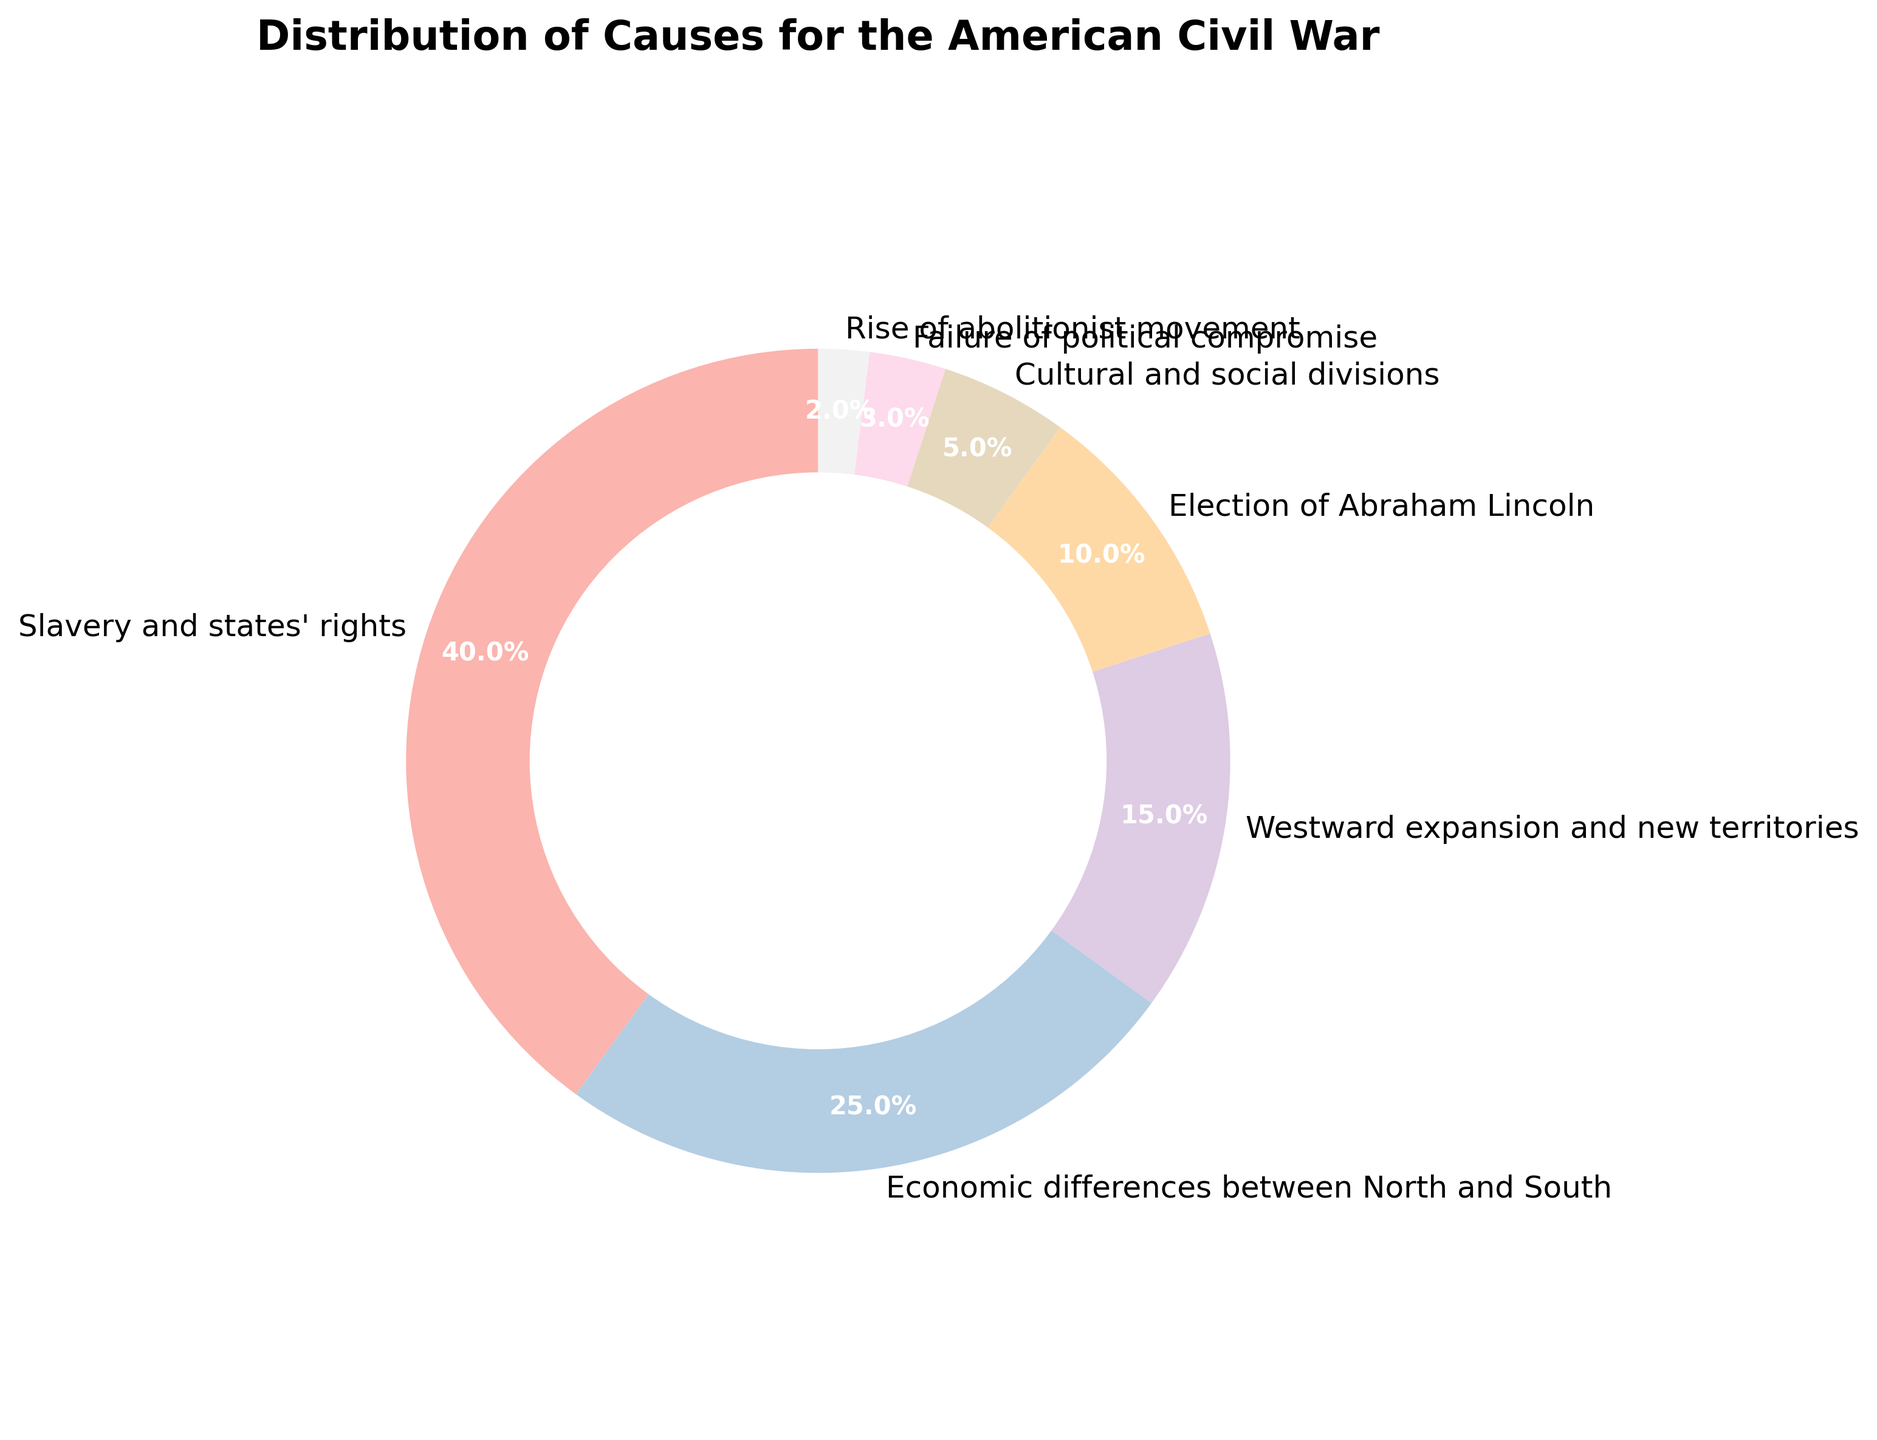What percentage of the causes is attributed to "Economic differences between North and South" and "Westward expansion and new territories" combined? First, identify the percentages for "Economic differences between North and South" (25%) and "Westward expansion and new territories" (15%). Then, add them together: 25% + 15% = 40%.
Answer: 40% How much greater is the percentage of "Slavery and states' rights" compared to the "Election of Abraham Lincoln"? First, look at the percentage of "Slavery and states' rights" (40%) and the percentage of "Election of Abraham Lincoln" (10%). Then, subtract the latter from the former: 40% - 10% = 30%.
Answer: 30% What percentage of the chart is attributed to causes that are less than 10% each? Identify the percentages of causes less than 10%: "Cultural and social divisions" (5%), "Failure of political compromise" (3%), and "Rise of abolitionist movement" (2%). Then, add them up: 5% + 3% + 2% = 10%.
Answer: 10% Which cause has the smallest percentage and how much is it? Look at all the percentages and find the smallest one, which is "Rise of abolitionist movement" with 2%.
Answer: Rise of abolitionist movement, 2% Is the percentage of "Slavery and states' rights" more than twice the percentage of "Economic differences between North and South"? First, double the percentage of "Economic differences between North and South": 25% * 2 = 50%. Then, compare it to "Slavery and states' rights" (40%). Since 40% is less than 50%, the percentage is not more than twice.
Answer: No, it's not more than twice What is the combined percentage of causes that are at least 10% each? Identify the causes with percentages at least 10% and add them: "Slavery and states' rights" (40%), "Economic differences between North and South" (25%), "Westward expansion and new territories" (15%), and "Election of Abraham Lincoln" (10%). Then, sum them up: 40% + 25% + 15% + 10% = 90%.
Answer: 90% If you were to divide the pie chart into two sections, one containing "Slavery and states' rights" and "Economic differences between North and South" and the other with the remaining causes, what would be the percentage of each section? First, sum up the percentages of "Slavery and states' rights" (40%) and "Economic differences between North and South" (25%): 40% + 25% = 65%. The remaining causes add up to: 100% - 65% = 35%.
Answer: 65% and 35% What visual indicators (like color or position in the chart) make it easy to identify the largest cause? The largest cause, "Slavery and states' rights," is often positioned starting from the top of the chart and occupies the largest segment. Additionally, it may be highlighted in a distinct color (like the first color in a sequential palette).
Answer: Largest segment from top Are there more causes that are above or below 5% each in the chart? Identify the causes above 5%: "Slavery and states' rights" (40%), "Economic differences between North and South" (25%), "Westward expansion and new territories" (15%), and "Election of Abraham Lincoln" (10%)—total 4 causes. Identify the causes below 5%: "Cultural and social divisions" (5%), "Failure of political compromise" (3%), and "Rise of abolitionist movement" (2%)—total 3 causes. There are more causes above 5%.
Answer: More above 5% 